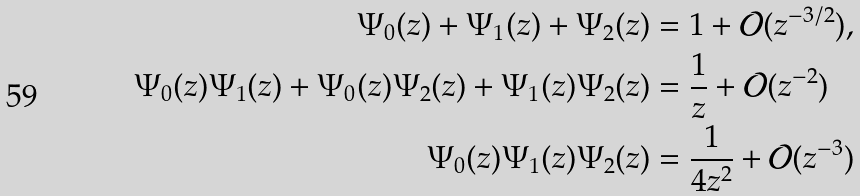Convert formula to latex. <formula><loc_0><loc_0><loc_500><loc_500>\Psi _ { 0 } ( z ) + \Psi _ { 1 } ( z ) + \Psi _ { 2 } ( z ) & = 1 + \mathcal { O } ( z ^ { - 3 / 2 } ) , \\ \Psi _ { 0 } ( z ) \Psi _ { 1 } ( z ) + \Psi _ { 0 } ( z ) \Psi _ { 2 } ( z ) + \Psi _ { 1 } ( z ) \Psi _ { 2 } ( z ) & = \frac { 1 } { z } + \mathcal { O } ( z ^ { - 2 } ) \\ \Psi _ { 0 } ( z ) \Psi _ { 1 } ( z ) \Psi _ { 2 } ( z ) & = \frac { 1 } { 4 z ^ { 2 } } + \mathcal { O } ( z ^ { - 3 } )</formula> 